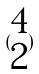Convert formula to latex. <formula><loc_0><loc_0><loc_500><loc_500>( \begin{matrix} 4 \\ 2 \end{matrix} )</formula> 